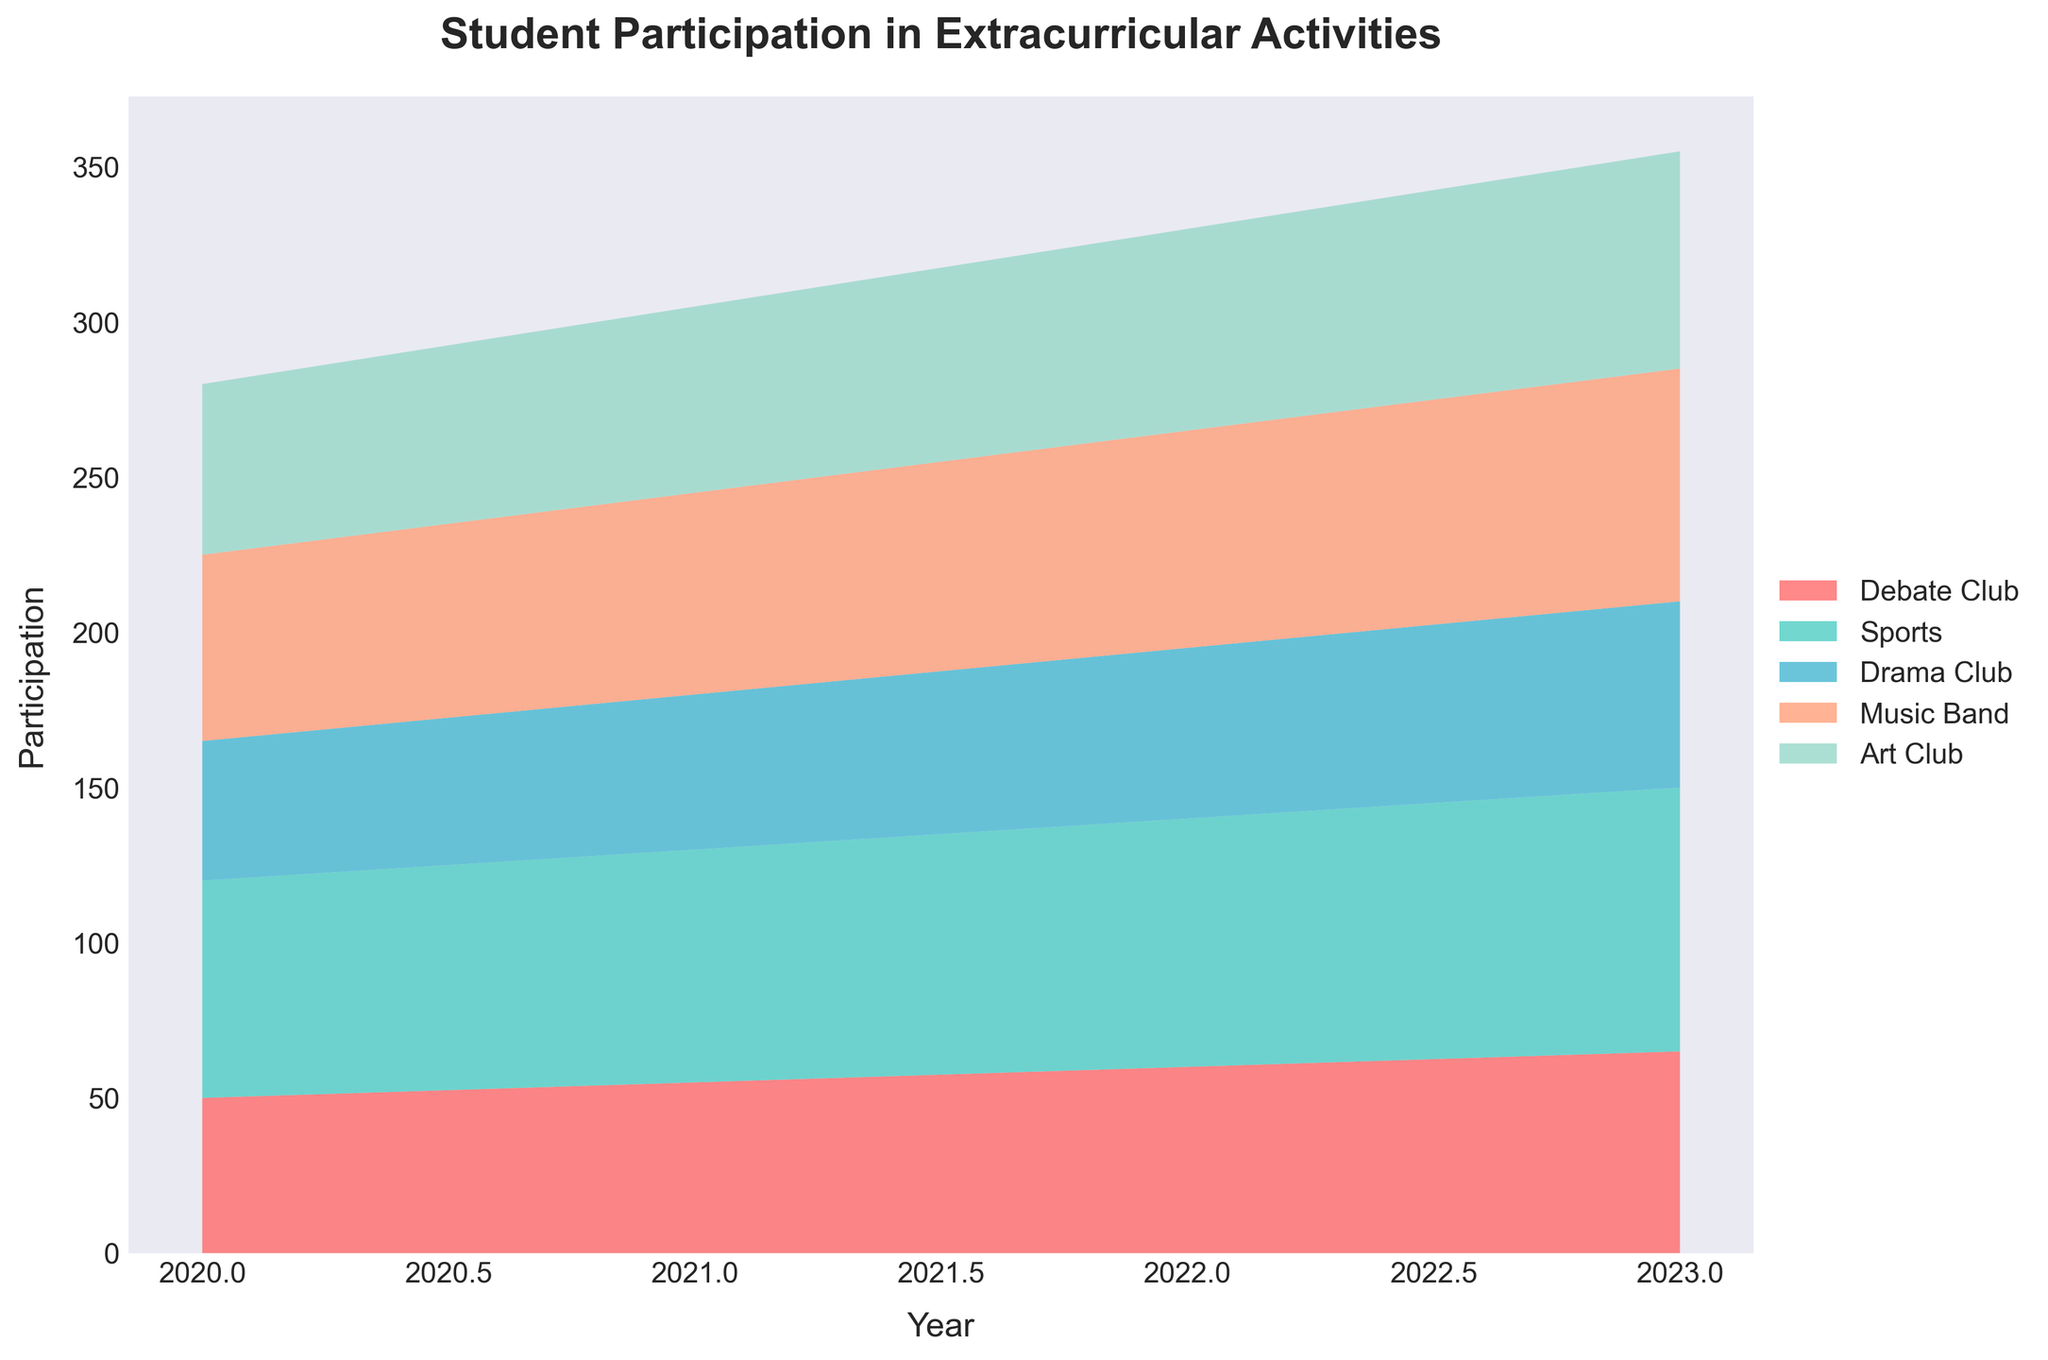What's the title of the figure? The title of the figure is usually found at the top and is designed to give an overview of what the figure represents. In this case, it should be clearly mentioned based on the code provided to generate the plot.
Answer: Student Participation in Extracurricular Activities What are the labels for the x-axis and y-axis in the figure? The x-axis and y-axis labels provide context for the data displayed in the figure. The x-axis shows the time frame or year, and the y-axis displays the measurement metric, which is the number of participants in this case.
Answer: Year, Participation Which extracurricular activity had the highest participation in 2023? To determine which activity had the highest participation, we look at the heights of the respective colored regions for the year 2023, based on the layer representing each activity.
Answer: Sports How does the participation in the Drama Club change from 2020 to 2023? To find this, observe the height of the Drama Club's region for each of the years from 2020 to 2023. The participation number is marked on the y-axis for each of the years.
Answer: It increased from 45 to 60 Which year had the overall highest total participation in extracurricular activities? Calculate the total participation for each year by summing the heights of all the activity layers for that year. Compare these totals to find the year with the highest sum.
Answer: 2023 What is the participation trend for the Debate Club over the given years? By observing the height of the Debate Club's region across the years on the x-axis, one can determine the trend of participation whether it is increasing, decreasing, or inconsistent.
Answer: Increasing Between Music Band and Art Club, which had greater participation on average from 2020 to 2023? Calculate the average participation for both the Music Band and Art Club over the four years by summing their participation numbers and dividing by the number of years (4). Compare the averages to find which one is higher.
Answer: Art Club How many unique extracurricular activities are depicted in the figure? The number of unique activities is represented by the different color regions in the stream graph. Count these distinct regions to get the answer.
Answer: 5 During which year did the participation in Sports see the largest increase from the previous year? To find this, compare the height of the Sports region year-over-year and identify the year with the largest increase. Calculate the difference between adjacent years and find the maximum.
Answer: 2022 What is the combined participation of Music Band and Drama Club in 2021? Find the heights of the Music Band and Drama Club regions for the year 2021 and sum these two values to get the combined participation.
Answer: 115 